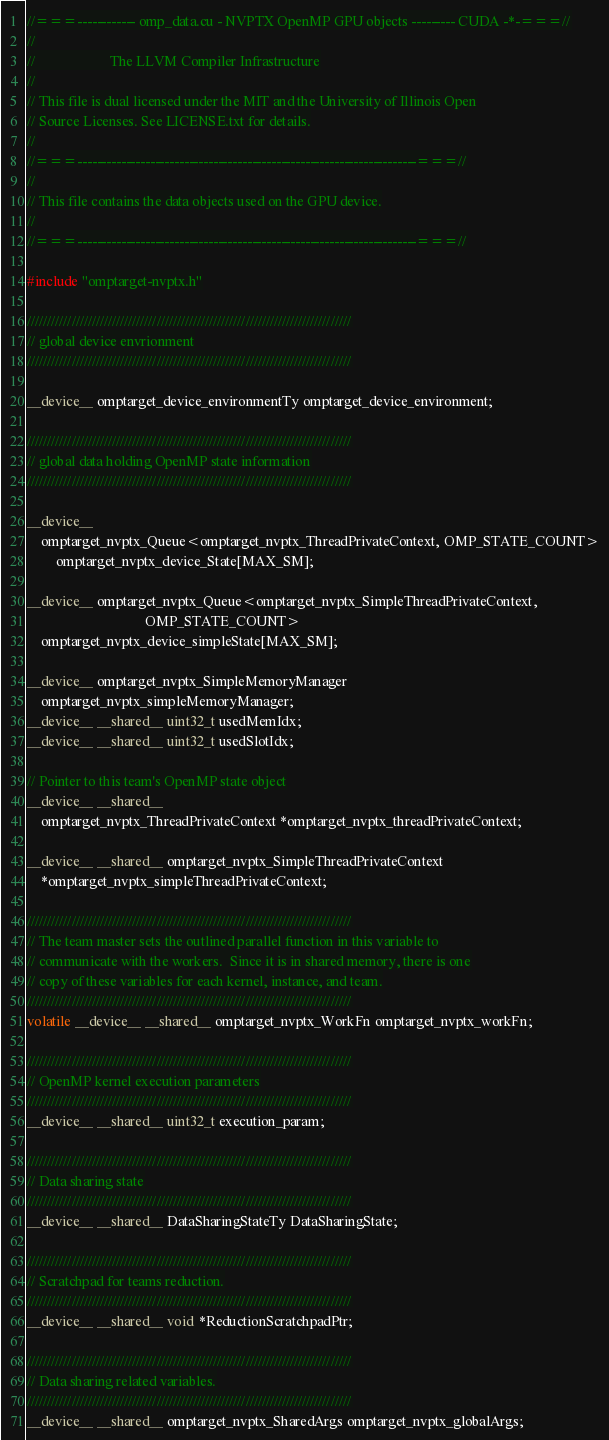<code> <loc_0><loc_0><loc_500><loc_500><_Cuda_>//===------------ omp_data.cu - NVPTX OpenMP GPU objects --------- CUDA -*-===//
//
//                     The LLVM Compiler Infrastructure
//
// This file is dual licensed under the MIT and the University of Illinois Open
// Source Licenses. See LICENSE.txt for details.
//
//===----------------------------------------------------------------------===//
//
// This file contains the data objects used on the GPU device.
//
//===----------------------------------------------------------------------===//

#include "omptarget-nvptx.h"

////////////////////////////////////////////////////////////////////////////////
// global device envrionment
////////////////////////////////////////////////////////////////////////////////

__device__ omptarget_device_environmentTy omptarget_device_environment;

////////////////////////////////////////////////////////////////////////////////
// global data holding OpenMP state information
////////////////////////////////////////////////////////////////////////////////

__device__
    omptarget_nvptx_Queue<omptarget_nvptx_ThreadPrivateContext, OMP_STATE_COUNT>
        omptarget_nvptx_device_State[MAX_SM];

__device__ omptarget_nvptx_Queue<omptarget_nvptx_SimpleThreadPrivateContext,
                                 OMP_STATE_COUNT>
    omptarget_nvptx_device_simpleState[MAX_SM];

__device__ omptarget_nvptx_SimpleMemoryManager
    omptarget_nvptx_simpleMemoryManager;
__device__ __shared__ uint32_t usedMemIdx;
__device__ __shared__ uint32_t usedSlotIdx;

// Pointer to this team's OpenMP state object
__device__ __shared__
    omptarget_nvptx_ThreadPrivateContext *omptarget_nvptx_threadPrivateContext;

__device__ __shared__ omptarget_nvptx_SimpleThreadPrivateContext
    *omptarget_nvptx_simpleThreadPrivateContext;

////////////////////////////////////////////////////////////////////////////////
// The team master sets the outlined parallel function in this variable to
// communicate with the workers.  Since it is in shared memory, there is one
// copy of these variables for each kernel, instance, and team.
////////////////////////////////////////////////////////////////////////////////
volatile __device__ __shared__ omptarget_nvptx_WorkFn omptarget_nvptx_workFn;

////////////////////////////////////////////////////////////////////////////////
// OpenMP kernel execution parameters
////////////////////////////////////////////////////////////////////////////////
__device__ __shared__ uint32_t execution_param;

////////////////////////////////////////////////////////////////////////////////
// Data sharing state
////////////////////////////////////////////////////////////////////////////////
__device__ __shared__ DataSharingStateTy DataSharingState;

////////////////////////////////////////////////////////////////////////////////
// Scratchpad for teams reduction.
////////////////////////////////////////////////////////////////////////////////
__device__ __shared__ void *ReductionScratchpadPtr;

////////////////////////////////////////////////////////////////////////////////
// Data sharing related variables.
////////////////////////////////////////////////////////////////////////////////
__device__ __shared__ omptarget_nvptx_SharedArgs omptarget_nvptx_globalArgs;
</code> 